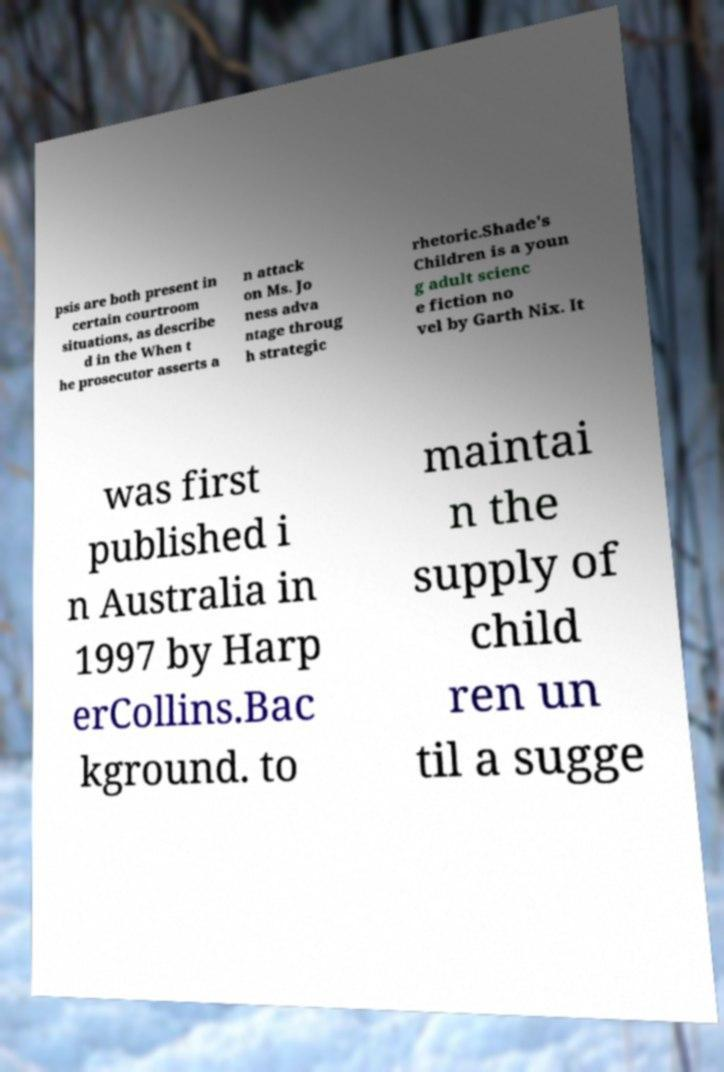Can you accurately transcribe the text from the provided image for me? psis are both present in certain courtroom situations, as describe d in the When t he prosecutor asserts a n attack on Ms. Jo ness adva ntage throug h strategic rhetoric.Shade's Children is a youn g adult scienc e fiction no vel by Garth Nix. It was first published i n Australia in 1997 by Harp erCollins.Bac kground. to maintai n the supply of child ren un til a sugge 